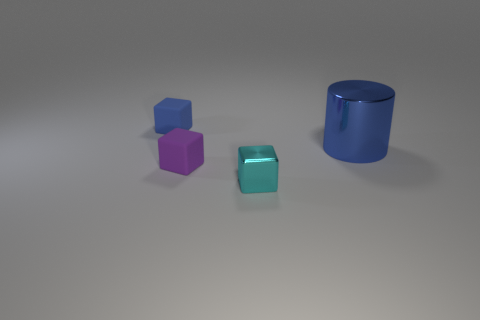Subtract all small rubber blocks. How many blocks are left? 1 Subtract all purple blocks. How many blocks are left? 2 Subtract all cylinders. How many objects are left? 3 Subtract 1 cylinders. How many cylinders are left? 0 Add 2 purple blocks. How many objects exist? 6 Subtract all gray cylinders. Subtract all gray cubes. How many cylinders are left? 1 Subtract all metal things. Subtract all large blue metallic spheres. How many objects are left? 2 Add 3 cylinders. How many cylinders are left? 4 Add 1 shiny cylinders. How many shiny cylinders exist? 2 Subtract 0 green spheres. How many objects are left? 4 